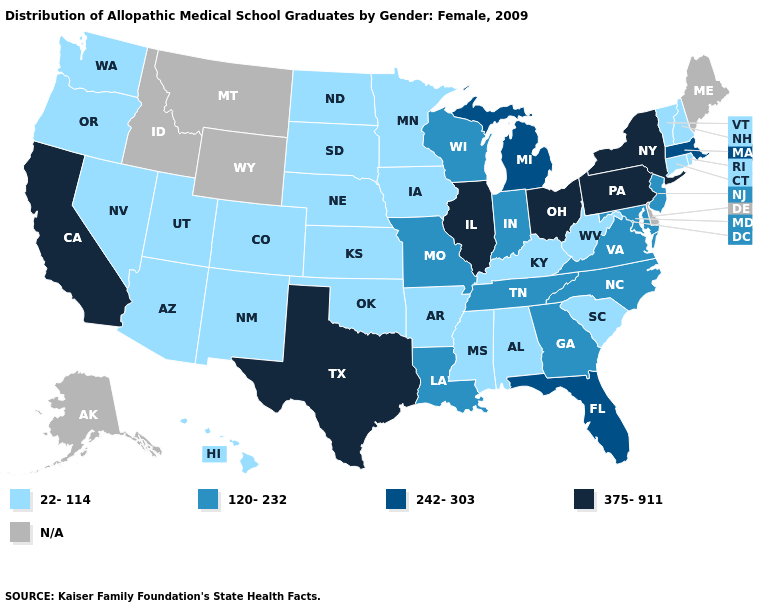Does the first symbol in the legend represent the smallest category?
Keep it brief. Yes. Name the states that have a value in the range 120-232?
Keep it brief. Georgia, Indiana, Louisiana, Maryland, Missouri, New Jersey, North Carolina, Tennessee, Virginia, Wisconsin. Which states have the highest value in the USA?
Concise answer only. California, Illinois, New York, Ohio, Pennsylvania, Texas. Name the states that have a value in the range 242-303?
Be succinct. Florida, Massachusetts, Michigan. Does the map have missing data?
Be succinct. Yes. What is the value of Missouri?
Answer briefly. 120-232. What is the value of Delaware?
Keep it brief. N/A. What is the value of Louisiana?
Write a very short answer. 120-232. Does Alabama have the highest value in the USA?
Be succinct. No. What is the highest value in states that border Nebraska?
Concise answer only. 120-232. Which states have the lowest value in the South?
Short answer required. Alabama, Arkansas, Kentucky, Mississippi, Oklahoma, South Carolina, West Virginia. Does the first symbol in the legend represent the smallest category?
Give a very brief answer. Yes. Name the states that have a value in the range 22-114?
Keep it brief. Alabama, Arizona, Arkansas, Colorado, Connecticut, Hawaii, Iowa, Kansas, Kentucky, Minnesota, Mississippi, Nebraska, Nevada, New Hampshire, New Mexico, North Dakota, Oklahoma, Oregon, Rhode Island, South Carolina, South Dakota, Utah, Vermont, Washington, West Virginia. 